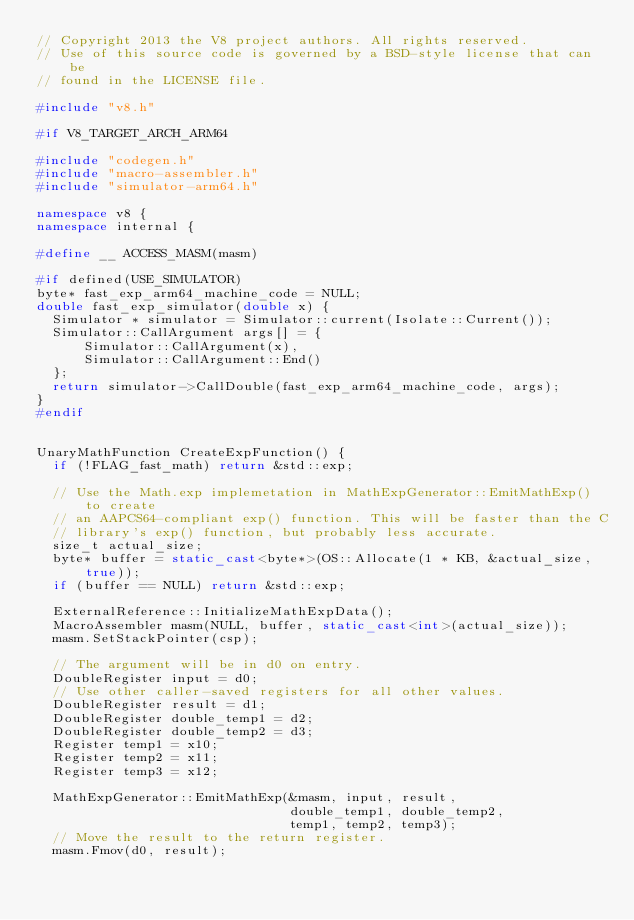Convert code to text. <code><loc_0><loc_0><loc_500><loc_500><_C++_>// Copyright 2013 the V8 project authors. All rights reserved.
// Use of this source code is governed by a BSD-style license that can be
// found in the LICENSE file.

#include "v8.h"

#if V8_TARGET_ARCH_ARM64

#include "codegen.h"
#include "macro-assembler.h"
#include "simulator-arm64.h"

namespace v8 {
namespace internal {

#define __ ACCESS_MASM(masm)

#if defined(USE_SIMULATOR)
byte* fast_exp_arm64_machine_code = NULL;
double fast_exp_simulator(double x) {
  Simulator * simulator = Simulator::current(Isolate::Current());
  Simulator::CallArgument args[] = {
      Simulator::CallArgument(x),
      Simulator::CallArgument::End()
  };
  return simulator->CallDouble(fast_exp_arm64_machine_code, args);
}
#endif


UnaryMathFunction CreateExpFunction() {
  if (!FLAG_fast_math) return &std::exp;

  // Use the Math.exp implemetation in MathExpGenerator::EmitMathExp() to create
  // an AAPCS64-compliant exp() function. This will be faster than the C
  // library's exp() function, but probably less accurate.
  size_t actual_size;
  byte* buffer = static_cast<byte*>(OS::Allocate(1 * KB, &actual_size, true));
  if (buffer == NULL) return &std::exp;

  ExternalReference::InitializeMathExpData();
  MacroAssembler masm(NULL, buffer, static_cast<int>(actual_size));
  masm.SetStackPointer(csp);

  // The argument will be in d0 on entry.
  DoubleRegister input = d0;
  // Use other caller-saved registers for all other values.
  DoubleRegister result = d1;
  DoubleRegister double_temp1 = d2;
  DoubleRegister double_temp2 = d3;
  Register temp1 = x10;
  Register temp2 = x11;
  Register temp3 = x12;

  MathExpGenerator::EmitMathExp(&masm, input, result,
                                double_temp1, double_temp2,
                                temp1, temp2, temp3);
  // Move the result to the return register.
  masm.Fmov(d0, result);</code> 